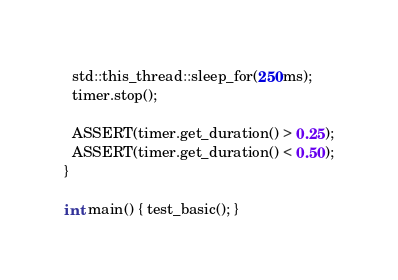<code> <loc_0><loc_0><loc_500><loc_500><_Cuda_>  std::this_thread::sleep_for(250ms);
  timer.stop();

  ASSERT(timer.get_duration() > 0.25);
  ASSERT(timer.get_duration() < 0.50);
}

int main() { test_basic(); }
</code> 